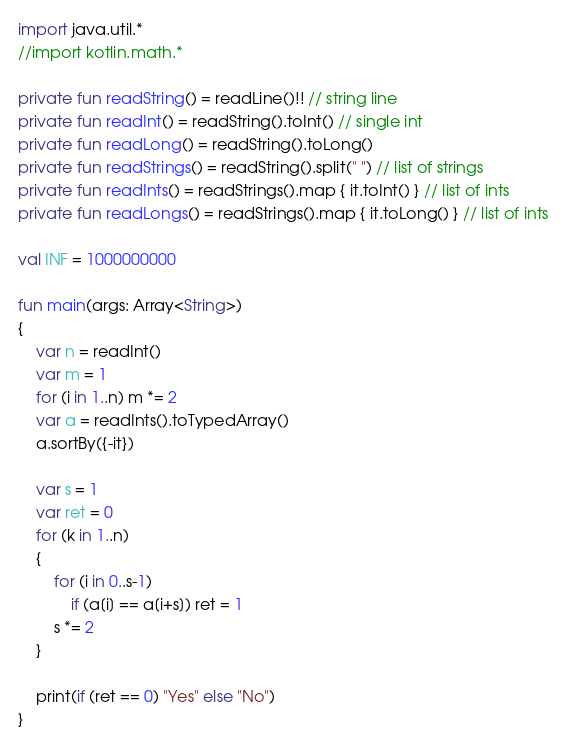Convert code to text. <code><loc_0><loc_0><loc_500><loc_500><_Kotlin_>import java.util.*
//import kotlin.math.*
 
private fun readString() = readLine()!! // string line
private fun readInt() = readString().toInt() // single int
private fun readLong() = readString().toLong()
private fun readStrings() = readString().split(" ") // list of strings
private fun readInts() = readStrings().map { it.toInt() } // list of ints
private fun readLongs() = readStrings().map { it.toLong() } // list of ints
 
val INF = 1000000000
 
fun main(args: Array<String>)
{
    var n = readInt()
	var m = 1
	for (i in 1..n) m *= 2
	var a = readInts().toTypedArray()
	a.sortBy({-it})
	
	var s = 1
	var ret = 0
	for (k in 1..n)
	{
		for (i in 0..s-1)
			if (a[i] == a[i+s]) ret = 1
		s *= 2
	}
	
	print(if (ret == 0) "Yes" else "No")
}
</code> 